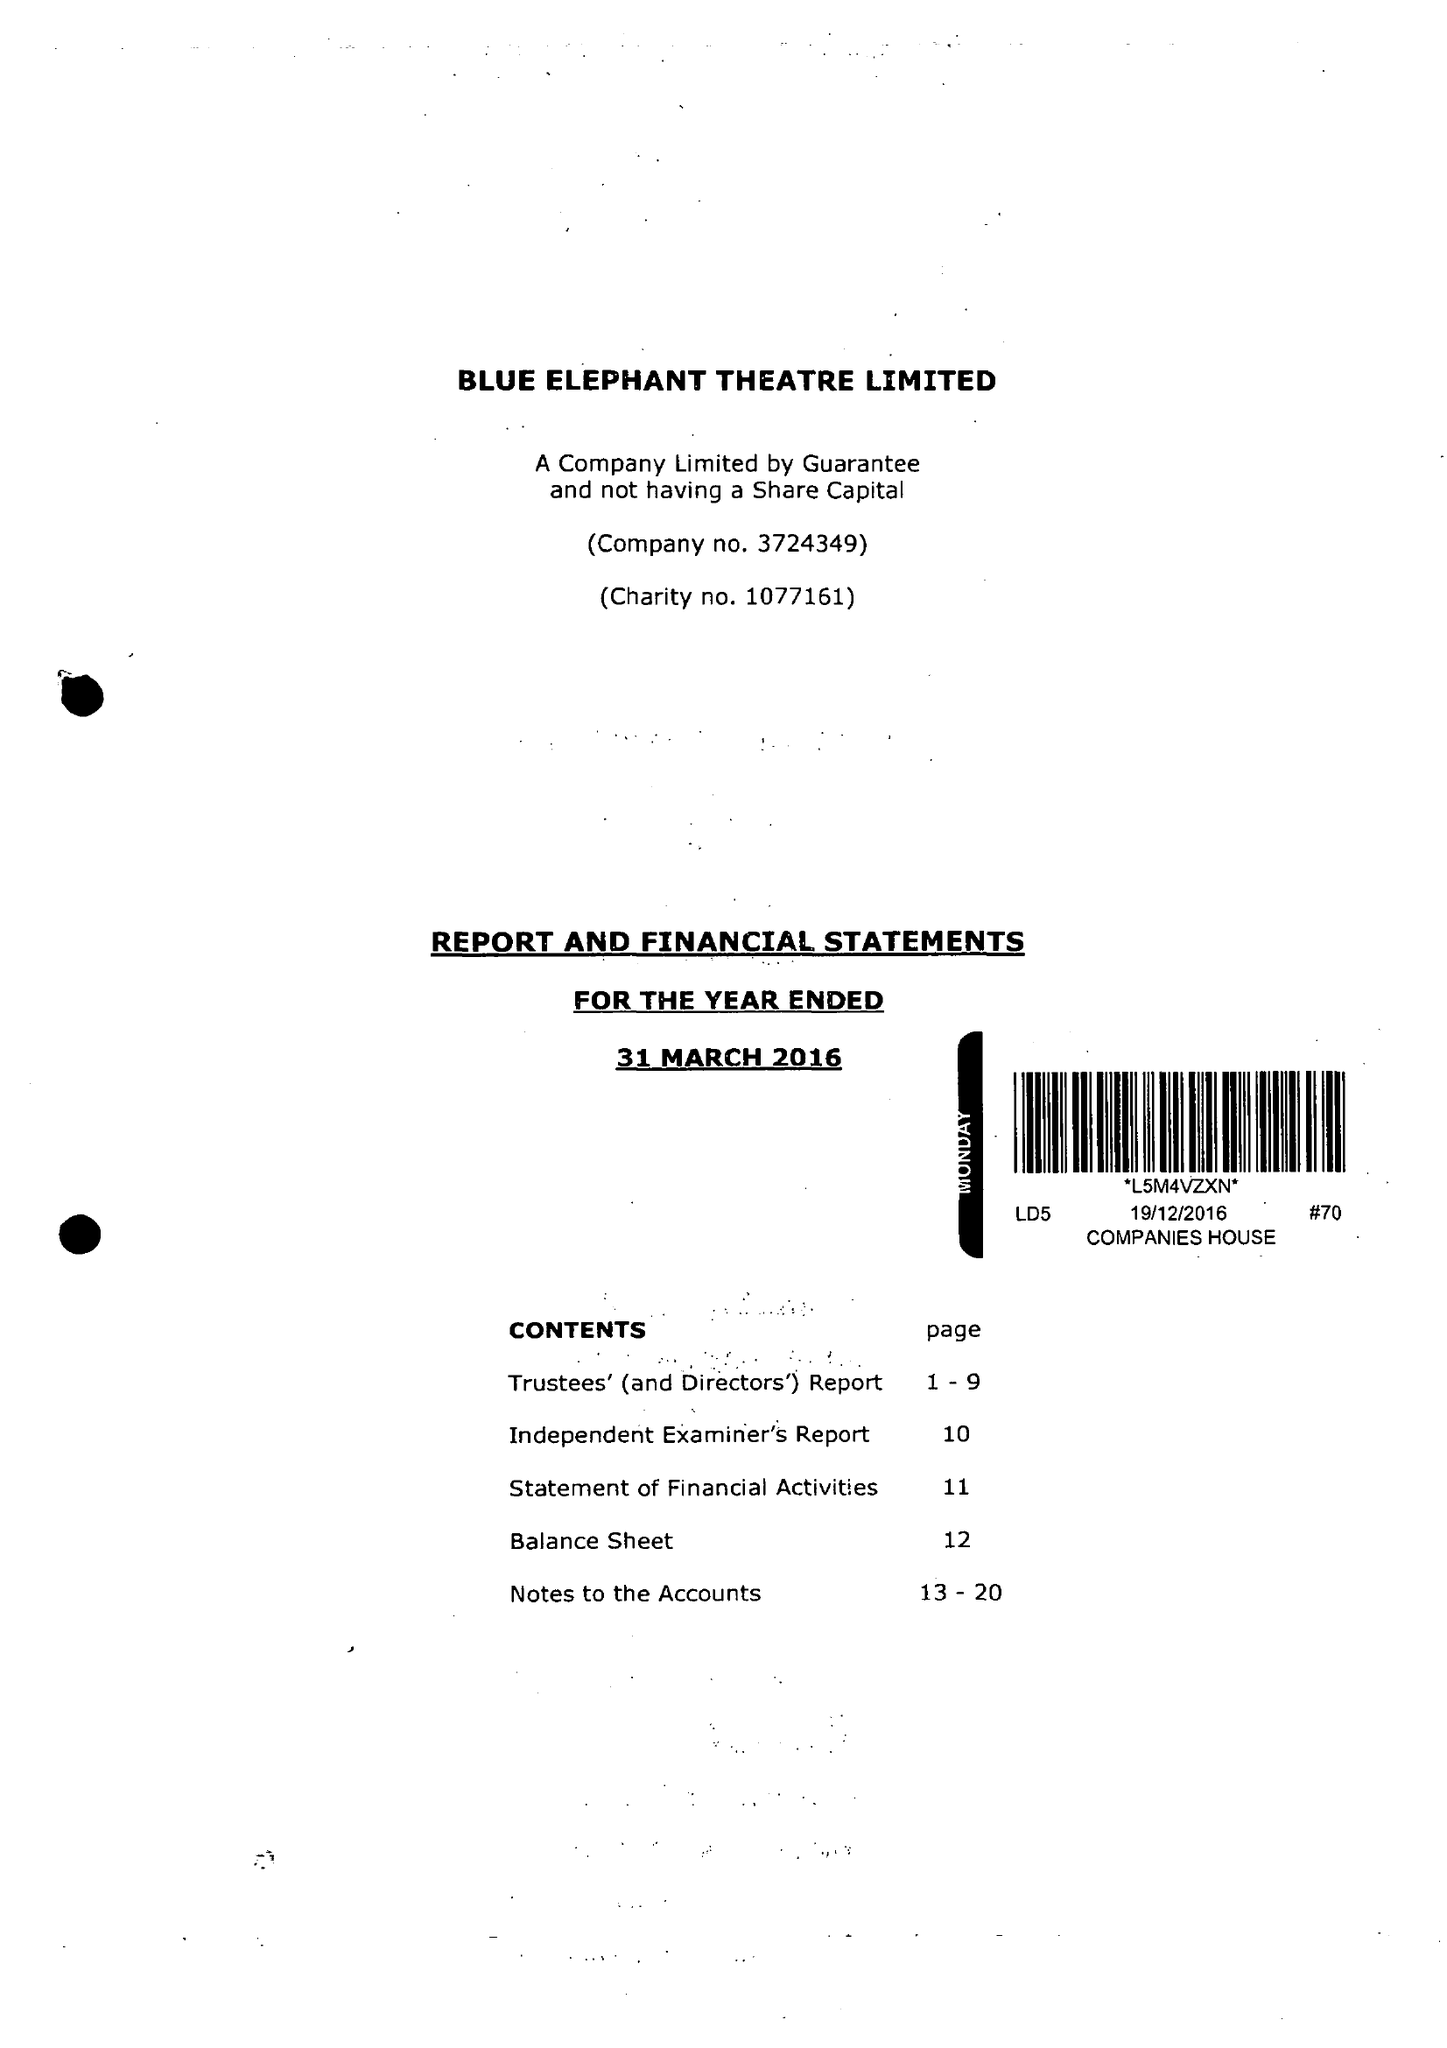What is the value for the address__post_town?
Answer the question using a single word or phrase. LONDON 